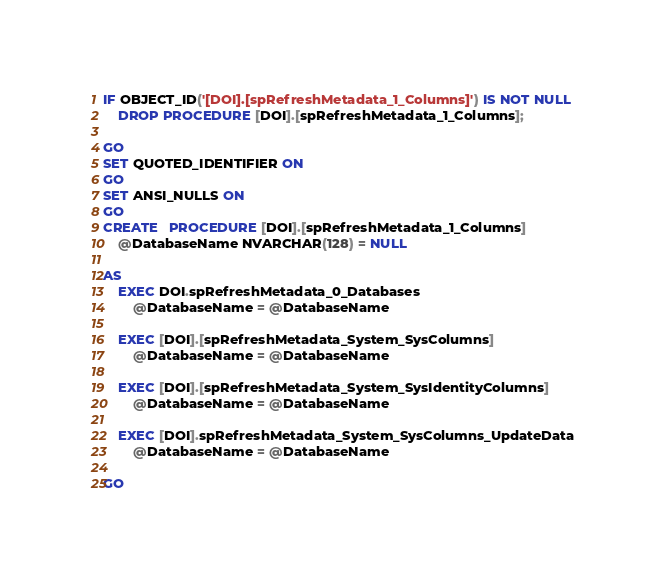Convert code to text. <code><loc_0><loc_0><loc_500><loc_500><_SQL_>IF OBJECT_ID('[DOI].[spRefreshMetadata_1_Columns]') IS NOT NULL
	DROP PROCEDURE [DOI].[spRefreshMetadata_1_Columns];

GO
SET QUOTED_IDENTIFIER ON
GO
SET ANSI_NULLS ON
GO
CREATE   PROCEDURE [DOI].[spRefreshMetadata_1_Columns]
    @DatabaseName NVARCHAR(128) = NULL

AS
    EXEC DOI.spRefreshMetadata_0_Databases
        @DatabaseName = @DatabaseName

    EXEC [DOI].[spRefreshMetadata_System_SysColumns]
        @DatabaseName = @DatabaseName

    EXEC [DOI].[spRefreshMetadata_System_SysIdentityColumns]
        @DatabaseName = @DatabaseName

    EXEC [DOI].spRefreshMetadata_System_SysColumns_UpdateData
        @DatabaseName = @DatabaseName

GO</code> 